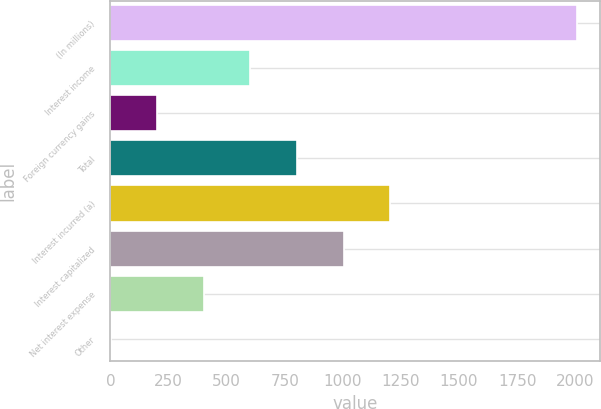Convert chart. <chart><loc_0><loc_0><loc_500><loc_500><bar_chart><fcel>(In millions)<fcel>Interest income<fcel>Foreign currency gains<fcel>Total<fcel>Interest incurred (a)<fcel>Interest capitalized<fcel>Net interest expense<fcel>Other<nl><fcel>2006<fcel>602.5<fcel>201.5<fcel>803<fcel>1204<fcel>1003.5<fcel>402<fcel>1<nl></chart> 